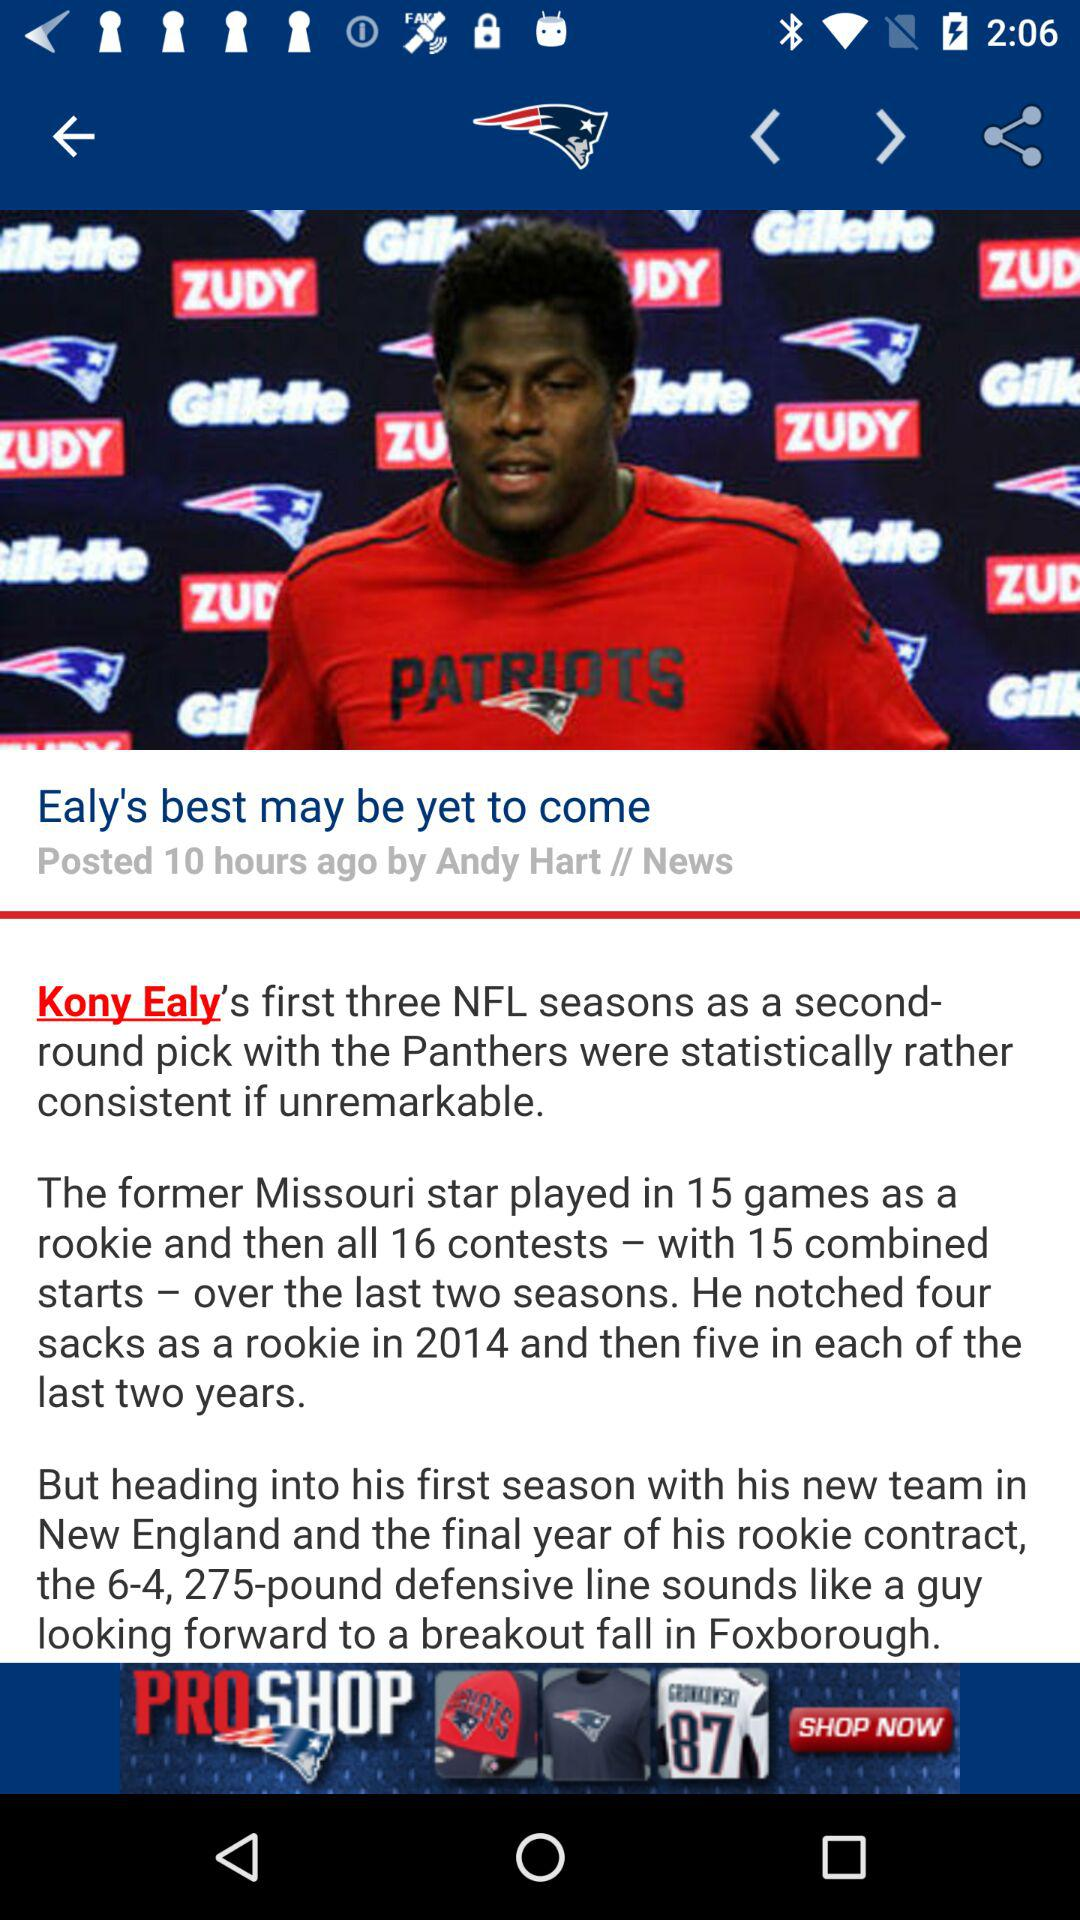Who posted "Ealy's best may be yet to come"? "Ealy's best may be yet to come" was posted by Andy Hart. 